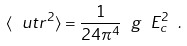Convert formula to latex. <formula><loc_0><loc_0><loc_500><loc_500>\langle \ u t r ^ { 2 } \rangle = \frac { 1 } { 2 4 \pi ^ { 4 } } \ g \ E _ { c } ^ { 2 } \ .</formula> 